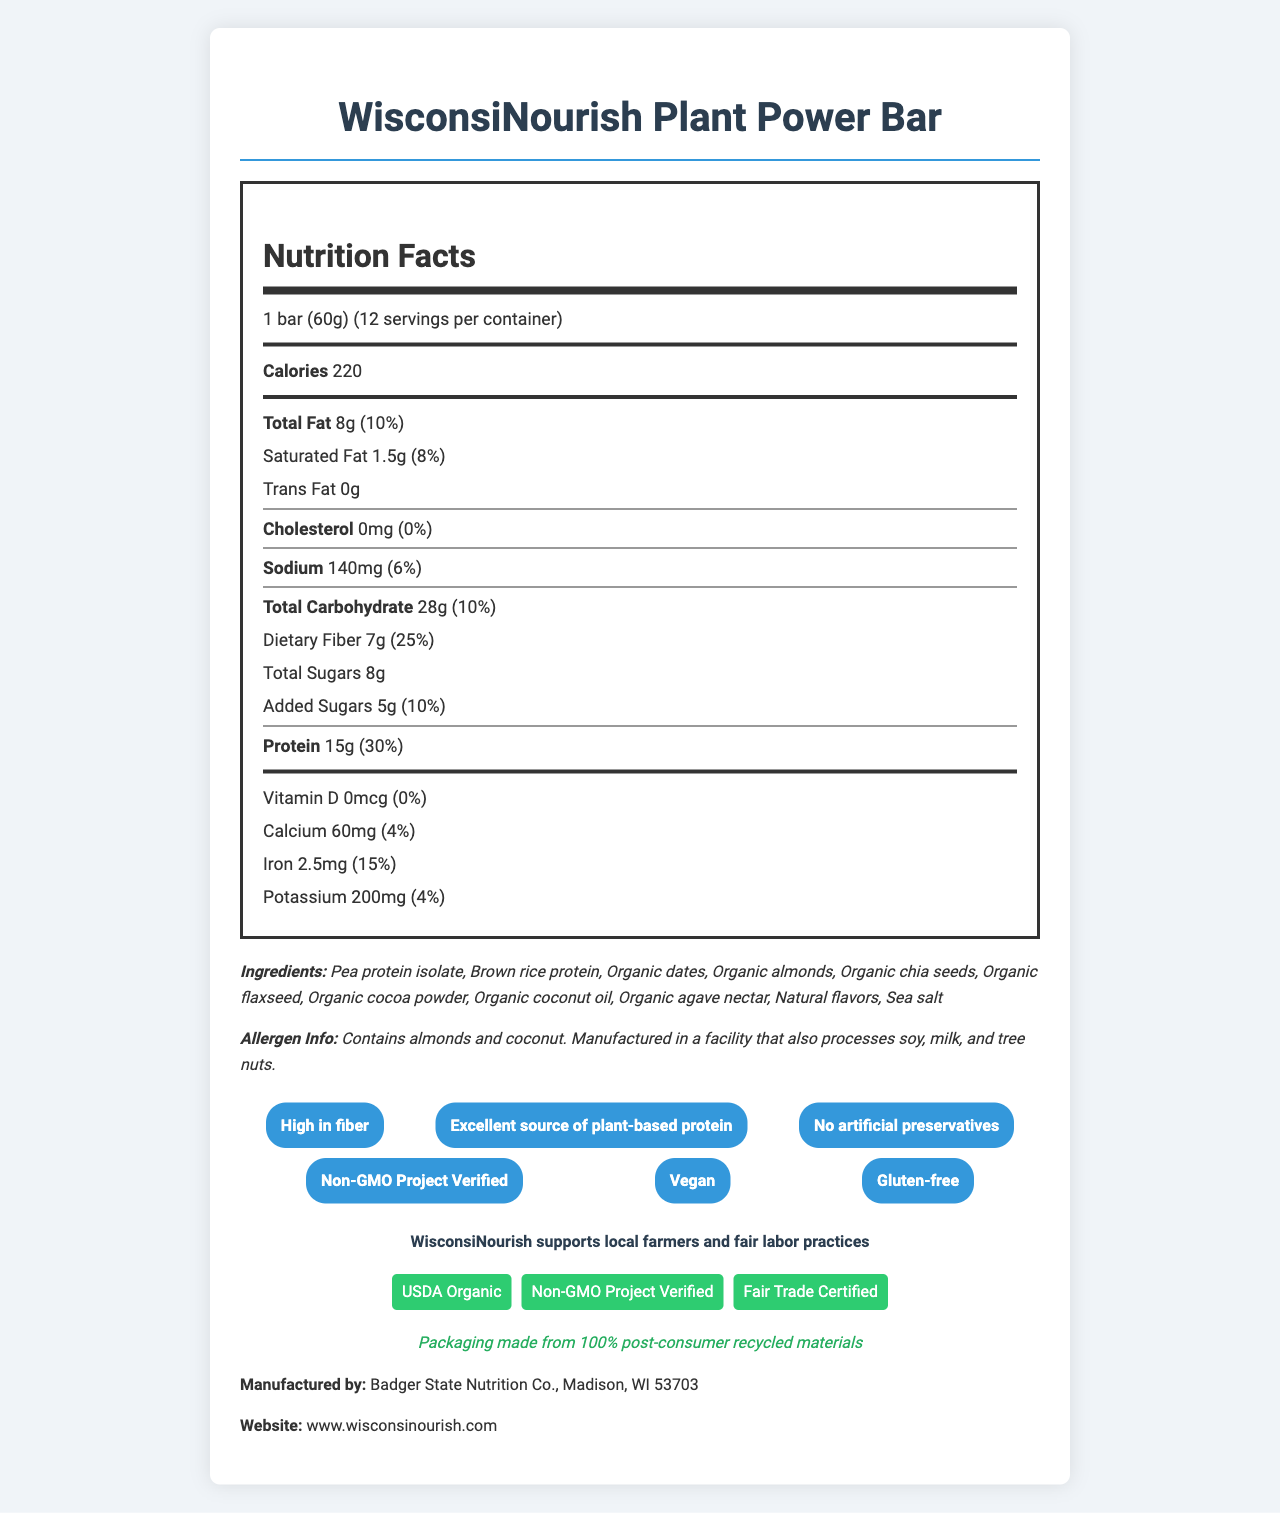what is the product name? The product name is clearly listed at the top of the document as "WisconsiNourish Plant Power Bar."
Answer: WisconsiNourish Plant Power Bar what is the serving size? The serving size is listed right below the product name in the Nutrition Facts section as "1 bar (60g)."
Answer: 1 bar (60g) how many servings are in a container? The number of servings per container is listed right under the serving size as "12."
Answer: 12 what are the calories per serving? The number of calories per serving is highlighted in the Nutrition Facts section as “220.”
Answer: 220 which ingredient is mentioned first in the ingredients list? The ingredients list starts with "Pea protein isolate" which is displayed in the Ingredients section.
Answer: Pea protein isolate how much dietary fiber does each bar contain? The amount of dietary fiber is shown as "7g" under the total carbohydrate section in the Nutrition Facts.
Answer: 7g what percentage of the daily value of protein is provided by this bar? The daily value percentage for protein is listed as "30%" in the Nutrition Facts section.
Answer: 30% which of the following claims is not made about the product? A. Non-GMO Project Verified B. Gluten-free C. Contains artificial preservatives D. High in fiber The claim about containing artificial preservatives is not made, while the other options are provided in the claims section.
Answer: C. Contains artificial preservatives how much calcium does each bar provide? A. 40mg B. 50mg C. 60mg D. 70mg The amount of calcium is listed as "60mg" under the micronutrients in the Nutrition Facts section.
Answer: C. 60mg is this product gluten-free? One of the claim statements specifically mentions that the product is "Gluten-free."
Answer: Yes summarize the key information provided in this document. The summary encompasses the main nutrition facts, claims, certifications, and sustainability details provided in the document.
Answer: The document provides nutritional information for WisconsiNourish Plant Power Bar, highlighting its high protein (15g per bar) and fiber content (7g per bar). It lists all the ingredients and mentions allergen information. The bar is certified USDA Organic, Non-GMO Project Verified, and Fair Trade Certified. Additionally, the packaging is made from 100% post-consumer recycled materials. which company manufactures the WisconsiNourish Plant Power Bar? The manufacturer information specifies that "Badger State Nutrition Co." is the company that produces the bar.
Answer: Badger State Nutrition Co. what is the website of the manufacturer? The manufacturer's website is listed as "www.wisconsinourish.com."
Answer: www.wisconsinourish.com can you determine the price of the product from this document? The document does not provide any pricing information, hence it cannot be determined from the available details.
Answer: Not enough information 